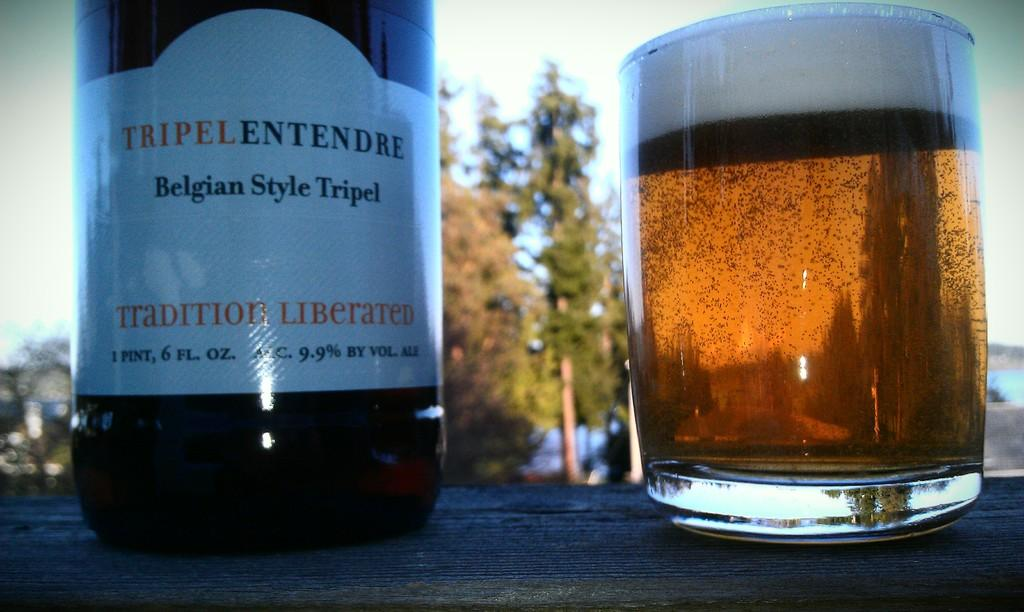<image>
Summarize the visual content of the image. A bottle of Belgian style tripel sits next to a full glass. 